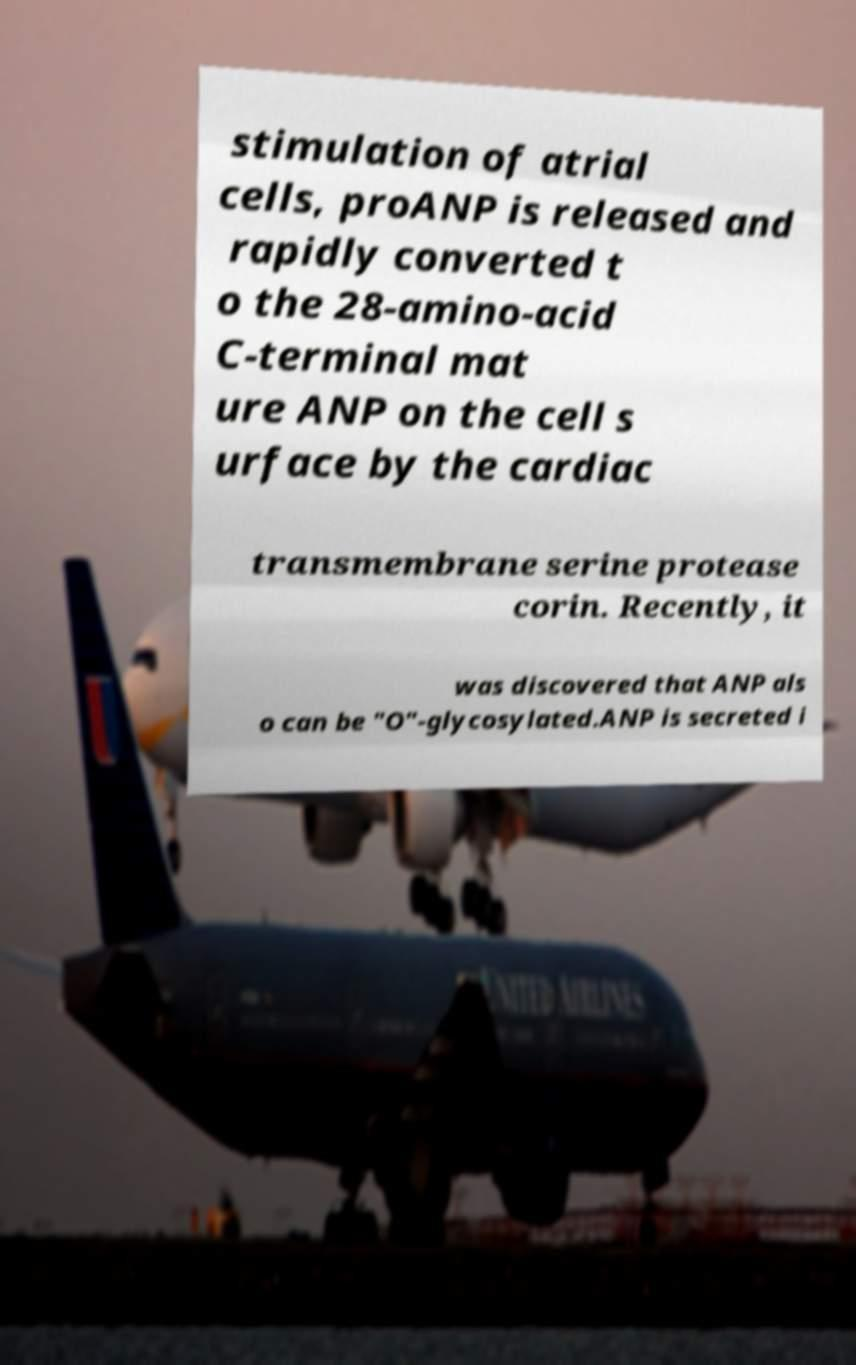There's text embedded in this image that I need extracted. Can you transcribe it verbatim? stimulation of atrial cells, proANP is released and rapidly converted t o the 28-amino-acid C-terminal mat ure ANP on the cell s urface by the cardiac transmembrane serine protease corin. Recently, it was discovered that ANP als o can be "O"-glycosylated.ANP is secreted i 